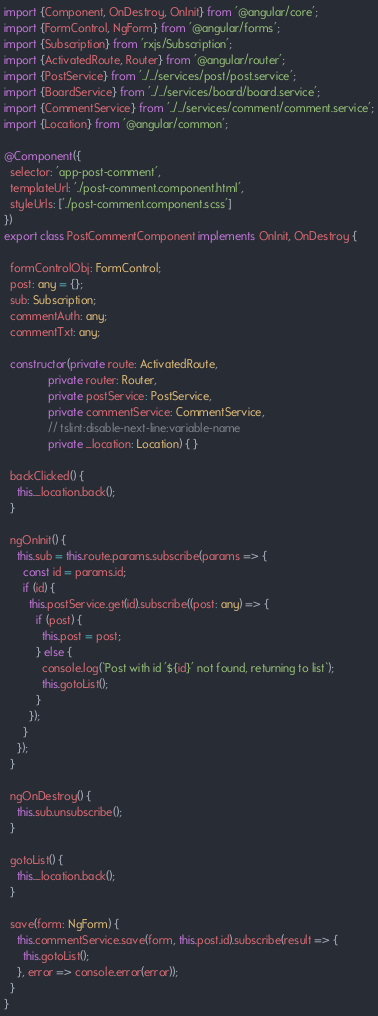Convert code to text. <code><loc_0><loc_0><loc_500><loc_500><_TypeScript_>import {Component, OnDestroy, OnInit} from '@angular/core';
import {FormControl, NgForm} from '@angular/forms';
import {Subscription} from 'rxjs/Subscription';
import {ActivatedRoute, Router} from '@angular/router';
import {PostService} from '../../services/post/post.service';
import {BoardService} from '../../services/board/board.service';
import {CommentService} from '../../services/comment/comment.service';
import {Location} from '@angular/common';

@Component({
  selector: 'app-post-comment',
  templateUrl: './post-comment.component.html',
  styleUrls: ['./post-comment.component.scss']
})
export class PostCommentComponent implements OnInit, OnDestroy {

  formControlObj: FormControl;
  post: any = {};
  sub: Subscription;
  commentAuth: any;
  commentTxt: any;

  constructor(private route: ActivatedRoute,
              private router: Router,
              private postService: PostService,
              private commentService: CommentService,
              // tslint:disable-next-line:variable-name
              private _location: Location) { }

  backClicked() {
    this._location.back();
  }

  ngOnInit() {
    this.sub = this.route.params.subscribe(params => {
      const id = params.id;
      if (id) {
        this.postService.get(id).subscribe((post: any) => {
          if (post) {
            this.post = post;
          } else {
            console.log(`Post with id '${id}' not found, returning to list`);
            this.gotoList();
          }
        });
      }
    });
  }

  ngOnDestroy() {
    this.sub.unsubscribe();
  }

  gotoList() {
    this._location.back();
  }

  save(form: NgForm) {
    this.commentService.save(form, this.post.id).subscribe(result => {
      this.gotoList();
    }, error => console.error(error));
  }
}
</code> 